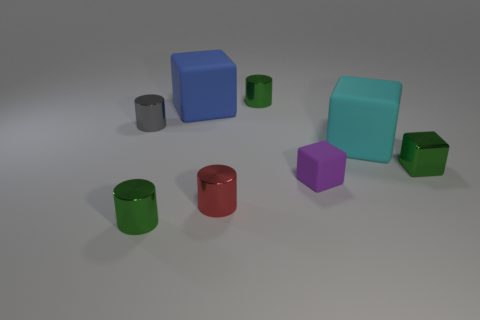Subtract all green blocks. How many blocks are left? 3 Add 2 tiny cubes. How many objects exist? 10 Subtract all cyan cubes. How many green cylinders are left? 2 Subtract 1 cylinders. How many cylinders are left? 3 Subtract all cyan cubes. How many cubes are left? 3 Subtract 1 purple blocks. How many objects are left? 7 Subtract all purple blocks. Subtract all red balls. How many blocks are left? 3 Subtract all purple blocks. Subtract all shiny cylinders. How many objects are left? 3 Add 8 small purple cubes. How many small purple cubes are left? 9 Add 5 purple blocks. How many purple blocks exist? 6 